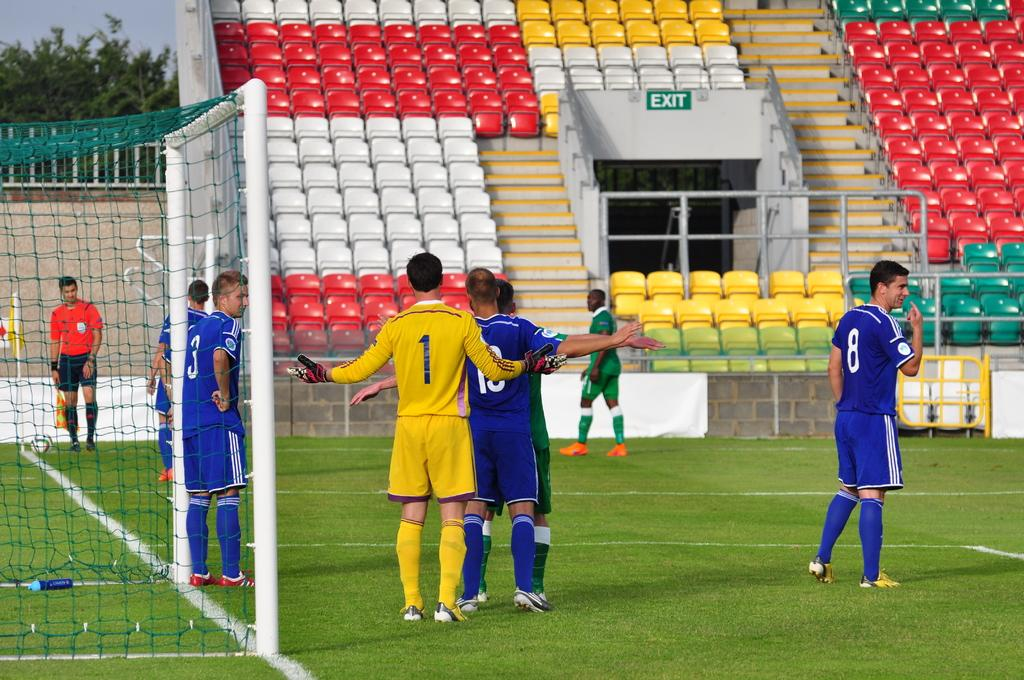<image>
Write a terse but informative summary of the picture. Numbers 1 and 18 fight for position before a corner kick. 